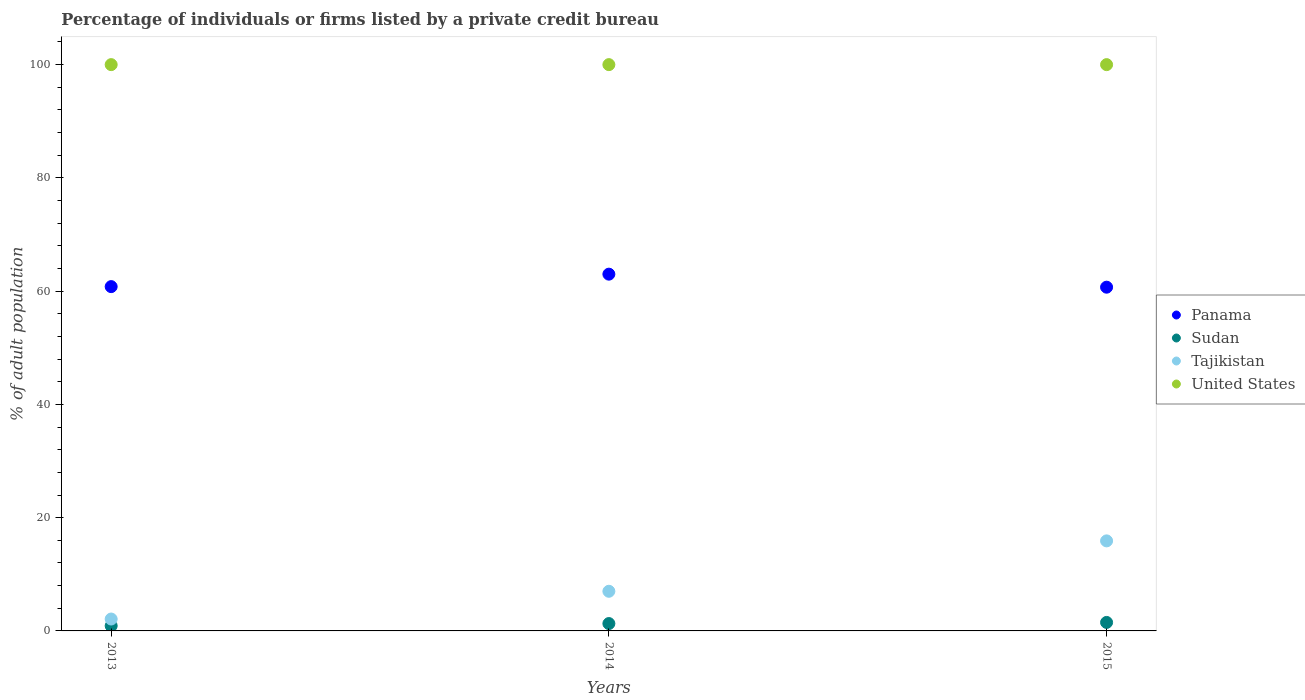How many different coloured dotlines are there?
Your response must be concise. 4. What is the percentage of population listed by a private credit bureau in Panama in 2015?
Your answer should be compact. 60.7. Across all years, what is the minimum percentage of population listed by a private credit bureau in Sudan?
Ensure brevity in your answer.  0.9. In which year was the percentage of population listed by a private credit bureau in Sudan maximum?
Give a very brief answer. 2015. What is the total percentage of population listed by a private credit bureau in United States in the graph?
Keep it short and to the point. 300. What is the difference between the percentage of population listed by a private credit bureau in Tajikistan in 2013 and that in 2014?
Offer a very short reply. -4.9. What is the difference between the percentage of population listed by a private credit bureau in United States in 2013 and the percentage of population listed by a private credit bureau in Panama in 2014?
Offer a terse response. 37. What is the average percentage of population listed by a private credit bureau in United States per year?
Give a very brief answer. 100. In the year 2013, what is the difference between the percentage of population listed by a private credit bureau in Sudan and percentage of population listed by a private credit bureau in United States?
Keep it short and to the point. -99.1. In how many years, is the percentage of population listed by a private credit bureau in United States greater than 36 %?
Your answer should be very brief. 3. Is the percentage of population listed by a private credit bureau in Tajikistan in 2013 less than that in 2015?
Provide a short and direct response. Yes. Is the difference between the percentage of population listed by a private credit bureau in Sudan in 2014 and 2015 greater than the difference between the percentage of population listed by a private credit bureau in United States in 2014 and 2015?
Provide a short and direct response. No. What is the difference between the highest and the lowest percentage of population listed by a private credit bureau in Panama?
Make the answer very short. 2.3. Is the sum of the percentage of population listed by a private credit bureau in Panama in 2013 and 2014 greater than the maximum percentage of population listed by a private credit bureau in Tajikistan across all years?
Provide a short and direct response. Yes. Is it the case that in every year, the sum of the percentage of population listed by a private credit bureau in Sudan and percentage of population listed by a private credit bureau in Panama  is greater than the sum of percentage of population listed by a private credit bureau in United States and percentage of population listed by a private credit bureau in Tajikistan?
Make the answer very short. No. Is the percentage of population listed by a private credit bureau in Tajikistan strictly greater than the percentage of population listed by a private credit bureau in United States over the years?
Offer a terse response. No. What is the difference between two consecutive major ticks on the Y-axis?
Your answer should be very brief. 20. Are the values on the major ticks of Y-axis written in scientific E-notation?
Your answer should be very brief. No. Does the graph contain any zero values?
Your answer should be compact. No. What is the title of the graph?
Your answer should be compact. Percentage of individuals or firms listed by a private credit bureau. Does "Somalia" appear as one of the legend labels in the graph?
Provide a succinct answer. No. What is the label or title of the Y-axis?
Offer a terse response. % of adult population. What is the % of adult population of Panama in 2013?
Keep it short and to the point. 60.8. What is the % of adult population of Panama in 2014?
Offer a terse response. 63. What is the % of adult population of Sudan in 2014?
Ensure brevity in your answer.  1.3. What is the % of adult population of Tajikistan in 2014?
Offer a very short reply. 7. What is the % of adult population of Panama in 2015?
Your response must be concise. 60.7. What is the % of adult population of Tajikistan in 2015?
Offer a very short reply. 15.9. Across all years, what is the maximum % of adult population of Tajikistan?
Provide a succinct answer. 15.9. Across all years, what is the maximum % of adult population of United States?
Keep it short and to the point. 100. Across all years, what is the minimum % of adult population of Panama?
Offer a terse response. 60.7. Across all years, what is the minimum % of adult population of Tajikistan?
Your answer should be very brief. 2.1. Across all years, what is the minimum % of adult population of United States?
Offer a terse response. 100. What is the total % of adult population in Panama in the graph?
Your answer should be very brief. 184.5. What is the total % of adult population in Sudan in the graph?
Provide a succinct answer. 3.7. What is the total % of adult population of Tajikistan in the graph?
Provide a short and direct response. 25. What is the total % of adult population in United States in the graph?
Your answer should be very brief. 300. What is the difference between the % of adult population of Sudan in 2013 and that in 2014?
Make the answer very short. -0.4. What is the difference between the % of adult population in Panama in 2013 and that in 2015?
Make the answer very short. 0.1. What is the difference between the % of adult population of Panama in 2013 and the % of adult population of Sudan in 2014?
Ensure brevity in your answer.  59.5. What is the difference between the % of adult population of Panama in 2013 and the % of adult population of Tajikistan in 2014?
Your response must be concise. 53.8. What is the difference between the % of adult population in Panama in 2013 and the % of adult population in United States in 2014?
Offer a terse response. -39.2. What is the difference between the % of adult population of Sudan in 2013 and the % of adult population of Tajikistan in 2014?
Provide a succinct answer. -6.1. What is the difference between the % of adult population of Sudan in 2013 and the % of adult population of United States in 2014?
Offer a very short reply. -99.1. What is the difference between the % of adult population in Tajikistan in 2013 and the % of adult population in United States in 2014?
Make the answer very short. -97.9. What is the difference between the % of adult population of Panama in 2013 and the % of adult population of Sudan in 2015?
Ensure brevity in your answer.  59.3. What is the difference between the % of adult population of Panama in 2013 and the % of adult population of Tajikistan in 2015?
Make the answer very short. 44.9. What is the difference between the % of adult population of Panama in 2013 and the % of adult population of United States in 2015?
Provide a succinct answer. -39.2. What is the difference between the % of adult population of Sudan in 2013 and the % of adult population of United States in 2015?
Offer a terse response. -99.1. What is the difference between the % of adult population in Tajikistan in 2013 and the % of adult population in United States in 2015?
Give a very brief answer. -97.9. What is the difference between the % of adult population of Panama in 2014 and the % of adult population of Sudan in 2015?
Give a very brief answer. 61.5. What is the difference between the % of adult population in Panama in 2014 and the % of adult population in Tajikistan in 2015?
Keep it short and to the point. 47.1. What is the difference between the % of adult population in Panama in 2014 and the % of adult population in United States in 2015?
Make the answer very short. -37. What is the difference between the % of adult population of Sudan in 2014 and the % of adult population of Tajikistan in 2015?
Give a very brief answer. -14.6. What is the difference between the % of adult population of Sudan in 2014 and the % of adult population of United States in 2015?
Keep it short and to the point. -98.7. What is the difference between the % of adult population in Tajikistan in 2014 and the % of adult population in United States in 2015?
Your response must be concise. -93. What is the average % of adult population in Panama per year?
Offer a very short reply. 61.5. What is the average % of adult population of Sudan per year?
Give a very brief answer. 1.23. What is the average % of adult population of Tajikistan per year?
Make the answer very short. 8.33. What is the average % of adult population of United States per year?
Offer a very short reply. 100. In the year 2013, what is the difference between the % of adult population in Panama and % of adult population in Sudan?
Your answer should be compact. 59.9. In the year 2013, what is the difference between the % of adult population of Panama and % of adult population of Tajikistan?
Your answer should be very brief. 58.7. In the year 2013, what is the difference between the % of adult population of Panama and % of adult population of United States?
Keep it short and to the point. -39.2. In the year 2013, what is the difference between the % of adult population in Sudan and % of adult population in Tajikistan?
Give a very brief answer. -1.2. In the year 2013, what is the difference between the % of adult population in Sudan and % of adult population in United States?
Provide a short and direct response. -99.1. In the year 2013, what is the difference between the % of adult population of Tajikistan and % of adult population of United States?
Your answer should be compact. -97.9. In the year 2014, what is the difference between the % of adult population in Panama and % of adult population in Sudan?
Offer a very short reply. 61.7. In the year 2014, what is the difference between the % of adult population in Panama and % of adult population in United States?
Offer a terse response. -37. In the year 2014, what is the difference between the % of adult population of Sudan and % of adult population of Tajikistan?
Offer a terse response. -5.7. In the year 2014, what is the difference between the % of adult population of Sudan and % of adult population of United States?
Give a very brief answer. -98.7. In the year 2014, what is the difference between the % of adult population in Tajikistan and % of adult population in United States?
Your response must be concise. -93. In the year 2015, what is the difference between the % of adult population of Panama and % of adult population of Sudan?
Provide a succinct answer. 59.2. In the year 2015, what is the difference between the % of adult population of Panama and % of adult population of Tajikistan?
Provide a short and direct response. 44.8. In the year 2015, what is the difference between the % of adult population in Panama and % of adult population in United States?
Offer a very short reply. -39.3. In the year 2015, what is the difference between the % of adult population of Sudan and % of adult population of Tajikistan?
Keep it short and to the point. -14.4. In the year 2015, what is the difference between the % of adult population of Sudan and % of adult population of United States?
Your answer should be compact. -98.5. In the year 2015, what is the difference between the % of adult population in Tajikistan and % of adult population in United States?
Offer a terse response. -84.1. What is the ratio of the % of adult population of Panama in 2013 to that in 2014?
Offer a terse response. 0.97. What is the ratio of the % of adult population of Sudan in 2013 to that in 2014?
Offer a very short reply. 0.69. What is the ratio of the % of adult population in Panama in 2013 to that in 2015?
Ensure brevity in your answer.  1. What is the ratio of the % of adult population of Tajikistan in 2013 to that in 2015?
Offer a terse response. 0.13. What is the ratio of the % of adult population in Panama in 2014 to that in 2015?
Provide a short and direct response. 1.04. What is the ratio of the % of adult population in Sudan in 2014 to that in 2015?
Offer a very short reply. 0.87. What is the ratio of the % of adult population in Tajikistan in 2014 to that in 2015?
Offer a terse response. 0.44. What is the difference between the highest and the lowest % of adult population of Panama?
Offer a terse response. 2.3. 